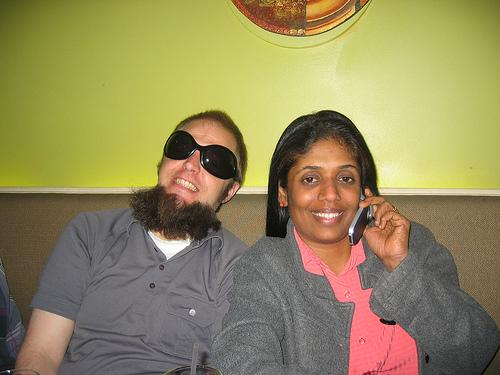What are the man and the woman doing together? The man and the woman are seated together in the image. What type of clothing are both the man and the woman wearing? The man is wearing a gray shirt and sunglasses, while the woman is wearing a pink shirt and a gray jacket. Describe one feature of the cell phone the woman is using. The woman is using a gray and black flip cell phone. Mention one interaction taking place between the man and the woman in the image. The woman in a pink shirt and gray jacket is talking on her cell phone while sitting next to a man in a gray shirt. How is the woman's outfit accessorized? The woman's outfit is accessorized with round red earrings. What is in front of the two main subjects of the picture? A cylindrical plastic drink cup with a clear straw is placed in front of the man and woman in the image. Describe one item of clothing the woman is wearing. The woman is wearing a pink shirt with a white button on it. What color is the wall behind the man and the woman? The wall behind the man and woman is green and brown. Mention one detail about the man's clothing. The man has a pocket on the front of his shirt. What key accessory does the man wear on his face? The man is wearing large black sunglasses on his face. 